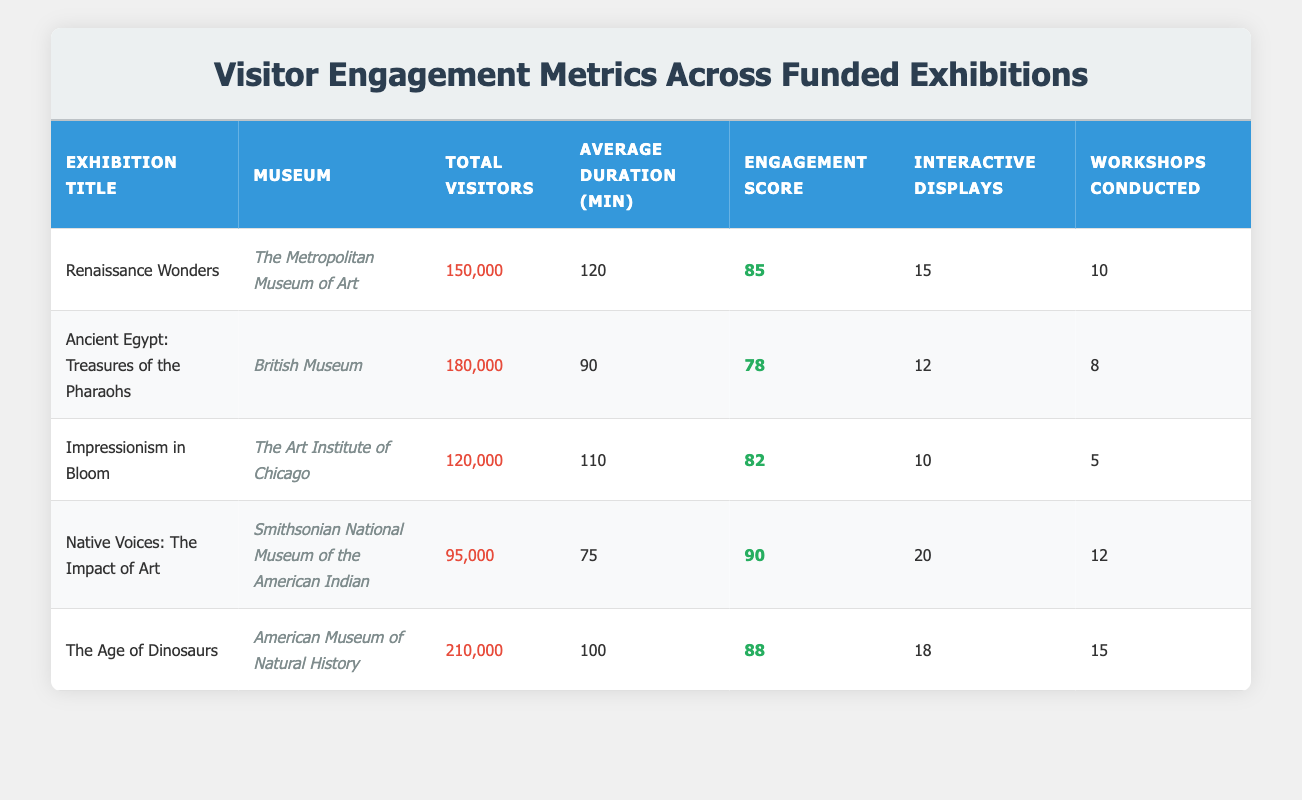What is the total number of visitors to the "Renaissance Wonders" exhibition? The data shows that the "Renaissance Wonders" exhibition had 150,000 total visitors listed in the table.
Answer: 150,000 Which exhibition has the highest engagement score? By comparing the engagement scores in the table, "Native Voices: The Impact of Art" has the highest score of 90.
Answer: Native Voices: The Impact of Art How many interactive displays were there in total across all exhibitions? The total number of interactive displays can be calculated by adding them from each exhibition: 15 + 12 + 10 + 20 + 18 = 85.
Answer: 85 Did the "Ancient Egypt: Treasures of the Pharaohs" have more total visitors than "Impressionism in Bloom"? The table indicates that "Ancient Egypt: Treasures of the Pharaohs" had 180,000 visitors, while "Impressionism in Bloom" had 120,000 visitors, meaning that the former had more visitors.
Answer: Yes What is the average duration of the exhibitions? To find the average duration, sum the average durations: 120 + 90 + 110 + 75 + 100 = 595. Then divide by the number of exhibitions (5): 595 / 5 = 119.
Answer: 119 What percentage of visitors to "The Age of Dinosaurs" engaged with interactive displays? "The Age of Dinosaurs" had 210,000 total visitors and 18 interactive displays. To find the percentage, calculate (18 / 210,000) * 100 = 0.00857%.
Answer: 0.00857% Is the average duration of visitors at the "Native Voices: The Impact of Art" exhibition greater than 80 minutes? The average duration listed for "Native Voices: The Impact of Art" is 75 minutes, which is not greater than 80 minutes.
Answer: No Which museum conducted the most workshops among the exhibitions? The table indicates that "The Age of Dinosaurs" and "Native Voices: The Impact of Art" each conducted 15 and 12 workshops respectively. However, "The Age of Dinosaurs" had conducted 15 workshops, which is the highest among all.
Answer: The Age of Dinosaurs 